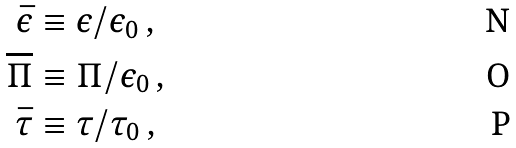<formula> <loc_0><loc_0><loc_500><loc_500>\bar { \epsilon } & \equiv \epsilon / \epsilon _ { 0 } \, , \\ \overline { \Pi } & \equiv \Pi / \epsilon _ { 0 } \, , \\ \bar { \tau } & \equiv \tau / \tau _ { 0 } \, ,</formula> 